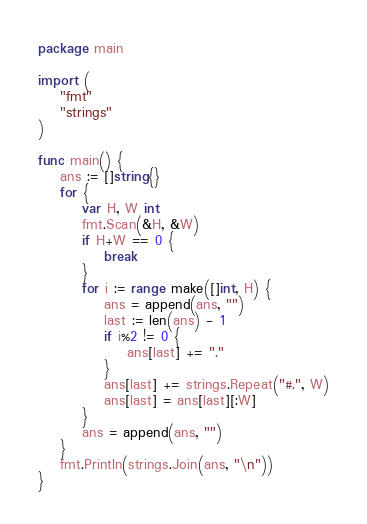<code> <loc_0><loc_0><loc_500><loc_500><_Go_>package main

import (
	"fmt"
	"strings"
)

func main() {
	ans := []string{}
	for {
		var H, W int
		fmt.Scan(&H, &W)
		if H+W == 0 {
			break
		}
		for i := range make([]int, H) {
			ans = append(ans, "")
			last := len(ans) - 1
			if i%2 != 0 {
				ans[last] += "."
			}
			ans[last] += strings.Repeat("#.", W)
			ans[last] = ans[last][:W]
		}
		ans = append(ans, "")
	}
	fmt.Println(strings.Join(ans, "\n"))
}

</code> 